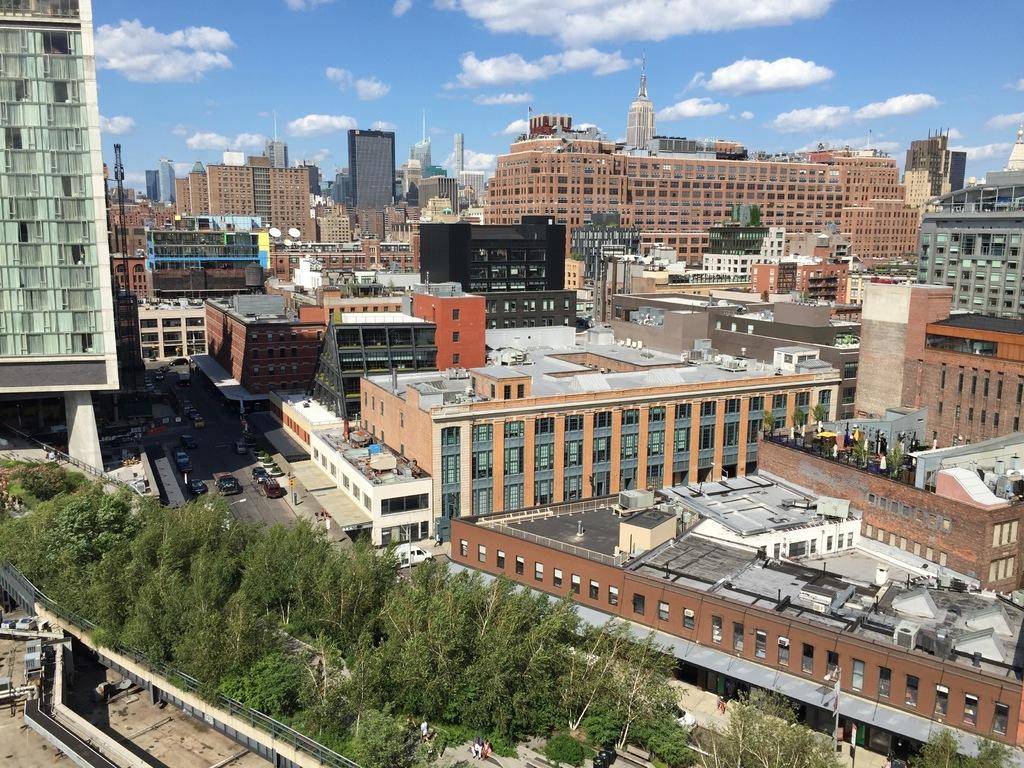What type of view is shown in the image? The image is an aerial view of a city. What can be seen in the foreground of the image? There are trees in the front of the image. What is visible in the background of the image? There are buildings in the background of the image. What part of the natural environment is visible in the image? The sky is visible in the image. What is the weather like in the image? The presence of clouds in the sky suggests that it might be partly cloudy. How many birthday books does the parent hold in the image? There is no parent or birthday books present in the image; it is an aerial view of a city with trees, buildings, and clouds. 